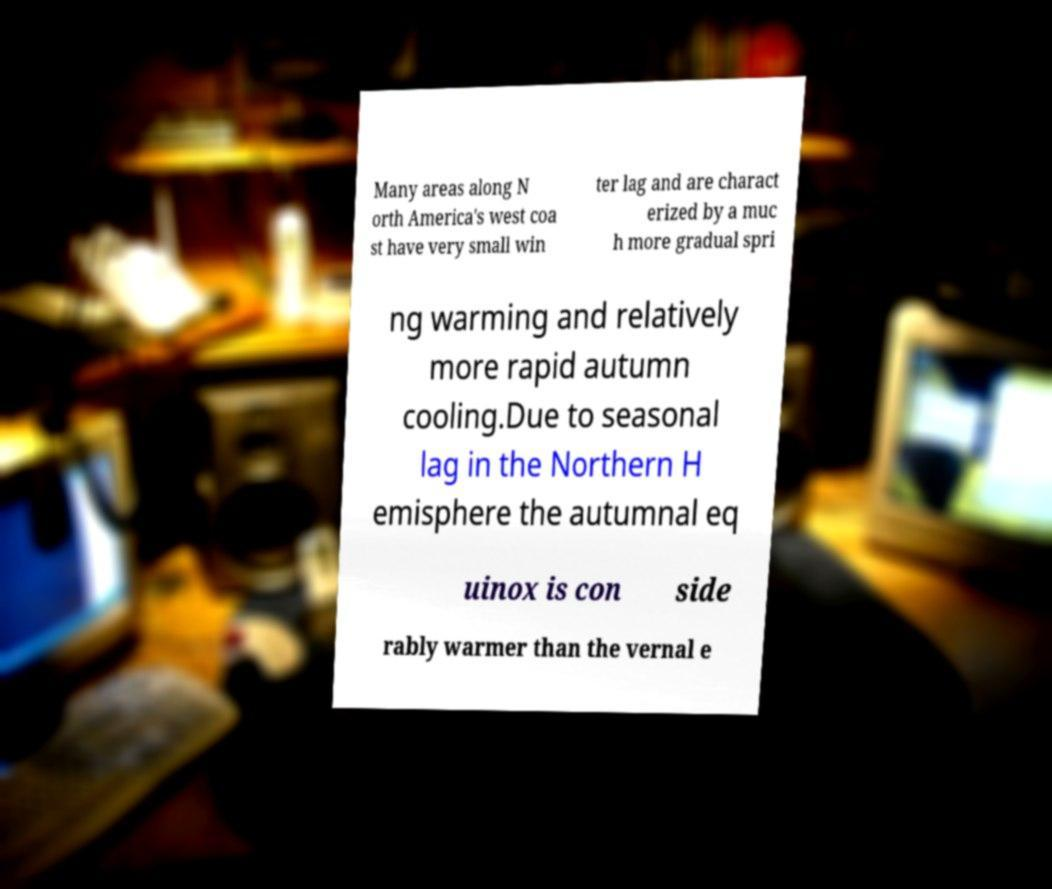Can you read and provide the text displayed in the image?This photo seems to have some interesting text. Can you extract and type it out for me? Many areas along N orth America's west coa st have very small win ter lag and are charact erized by a muc h more gradual spri ng warming and relatively more rapid autumn cooling.Due to seasonal lag in the Northern H emisphere the autumnal eq uinox is con side rably warmer than the vernal e 